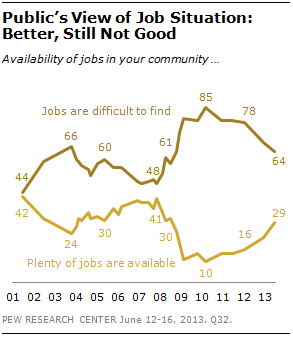Outline some significant characteristics in this image. The median of the first three data points of the dark brown line is 60. What is the value of the dark brown pixel on the right side of the graph? 